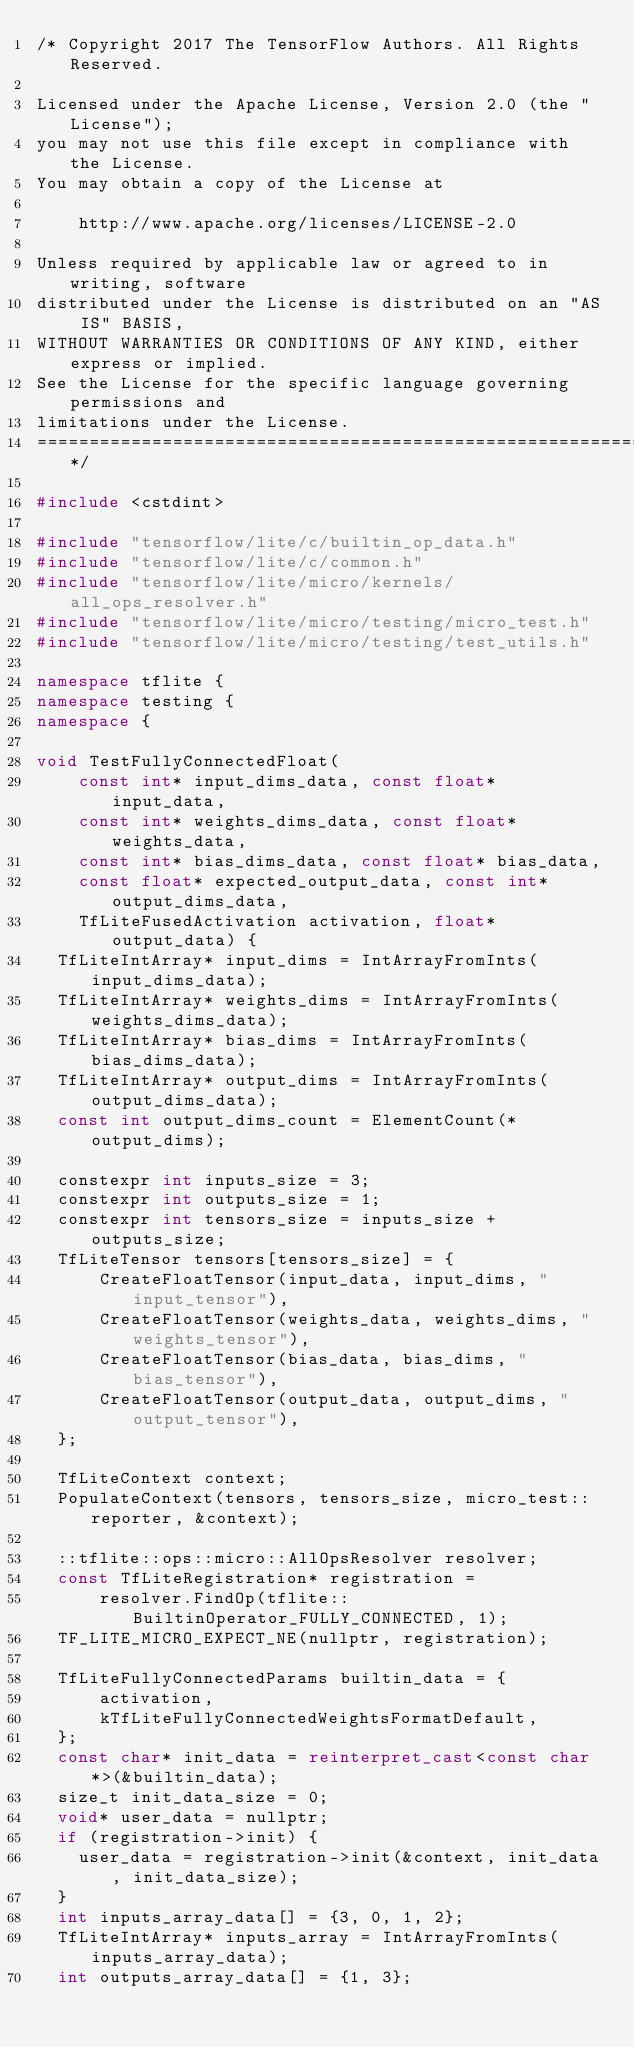Convert code to text. <code><loc_0><loc_0><loc_500><loc_500><_C++_>/* Copyright 2017 The TensorFlow Authors. All Rights Reserved.

Licensed under the Apache License, Version 2.0 (the "License");
you may not use this file except in compliance with the License.
You may obtain a copy of the License at

    http://www.apache.org/licenses/LICENSE-2.0

Unless required by applicable law or agreed to in writing, software
distributed under the License is distributed on an "AS IS" BASIS,
WITHOUT WARRANTIES OR CONDITIONS OF ANY KIND, either express or implied.
See the License for the specific language governing permissions and
limitations under the License.
==============================================================================*/

#include <cstdint>

#include "tensorflow/lite/c/builtin_op_data.h"
#include "tensorflow/lite/c/common.h"
#include "tensorflow/lite/micro/kernels/all_ops_resolver.h"
#include "tensorflow/lite/micro/testing/micro_test.h"
#include "tensorflow/lite/micro/testing/test_utils.h"

namespace tflite {
namespace testing {
namespace {

void TestFullyConnectedFloat(
    const int* input_dims_data, const float* input_data,
    const int* weights_dims_data, const float* weights_data,
    const int* bias_dims_data, const float* bias_data,
    const float* expected_output_data, const int* output_dims_data,
    TfLiteFusedActivation activation, float* output_data) {
  TfLiteIntArray* input_dims = IntArrayFromInts(input_dims_data);
  TfLiteIntArray* weights_dims = IntArrayFromInts(weights_dims_data);
  TfLiteIntArray* bias_dims = IntArrayFromInts(bias_dims_data);
  TfLiteIntArray* output_dims = IntArrayFromInts(output_dims_data);
  const int output_dims_count = ElementCount(*output_dims);

  constexpr int inputs_size = 3;
  constexpr int outputs_size = 1;
  constexpr int tensors_size = inputs_size + outputs_size;
  TfLiteTensor tensors[tensors_size] = {
      CreateFloatTensor(input_data, input_dims, "input_tensor"),
      CreateFloatTensor(weights_data, weights_dims, "weights_tensor"),
      CreateFloatTensor(bias_data, bias_dims, "bias_tensor"),
      CreateFloatTensor(output_data, output_dims, "output_tensor"),
  };

  TfLiteContext context;
  PopulateContext(tensors, tensors_size, micro_test::reporter, &context);

  ::tflite::ops::micro::AllOpsResolver resolver;
  const TfLiteRegistration* registration =
      resolver.FindOp(tflite::BuiltinOperator_FULLY_CONNECTED, 1);
  TF_LITE_MICRO_EXPECT_NE(nullptr, registration);

  TfLiteFullyConnectedParams builtin_data = {
      activation,
      kTfLiteFullyConnectedWeightsFormatDefault,
  };
  const char* init_data = reinterpret_cast<const char*>(&builtin_data);
  size_t init_data_size = 0;
  void* user_data = nullptr;
  if (registration->init) {
    user_data = registration->init(&context, init_data, init_data_size);
  }
  int inputs_array_data[] = {3, 0, 1, 2};
  TfLiteIntArray* inputs_array = IntArrayFromInts(inputs_array_data);
  int outputs_array_data[] = {1, 3};</code> 